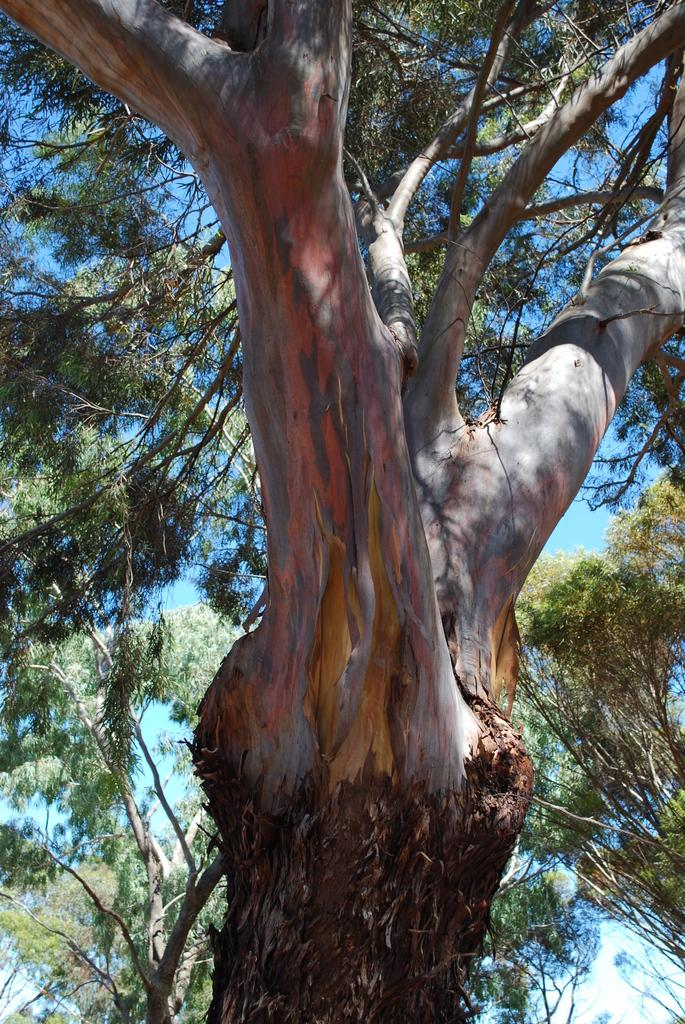What is the main subject of the image? The main subject of the image is the branches of a tree with leaves. Are there any other trees visible in the image? Yes, there is a group of trees in the background of the image. What can be seen in the sky in the background of the image? The sky is visible in the background of the image. Reasoning: Let' Let's think step by step in order to produce the conversation. We start by identifying the main subject of the image, which is the branches of a tree with leaves. Then, we expand the conversation to include other trees visible in the background and the sky. Each question is designed to elicit a specific detail about the image that is known from the provided facts. Absurd Question/Answer: What type of thrill can be seen on the branches of the tree in the image? There is no thrill present on the branches of the tree in the image; it is a natural scene with leaves and trees. 